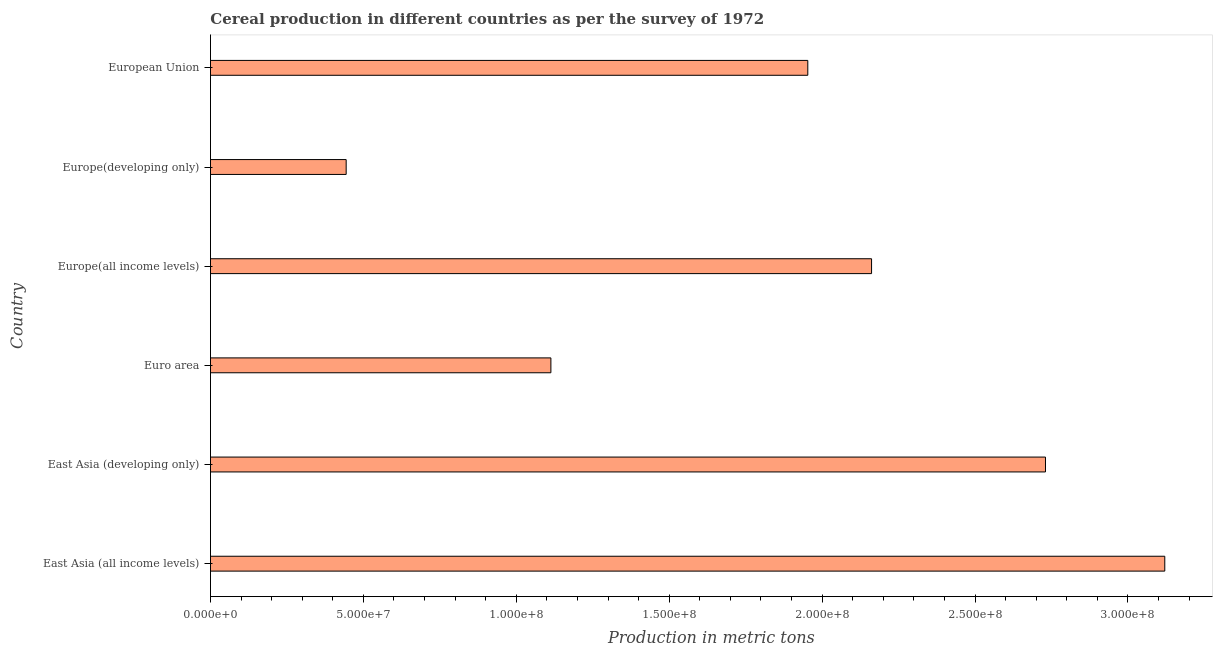Does the graph contain any zero values?
Give a very brief answer. No. Does the graph contain grids?
Offer a terse response. No. What is the title of the graph?
Keep it short and to the point. Cereal production in different countries as per the survey of 1972. What is the label or title of the X-axis?
Your answer should be very brief. Production in metric tons. What is the label or title of the Y-axis?
Keep it short and to the point. Country. What is the cereal production in Europe(developing only)?
Offer a terse response. 4.44e+07. Across all countries, what is the maximum cereal production?
Make the answer very short. 3.12e+08. Across all countries, what is the minimum cereal production?
Offer a very short reply. 4.44e+07. In which country was the cereal production maximum?
Ensure brevity in your answer.  East Asia (all income levels). In which country was the cereal production minimum?
Offer a terse response. Europe(developing only). What is the sum of the cereal production?
Make the answer very short. 1.15e+09. What is the difference between the cereal production in Europe(developing only) and European Union?
Keep it short and to the point. -1.51e+08. What is the average cereal production per country?
Provide a succinct answer. 1.92e+08. What is the median cereal production?
Give a very brief answer. 2.06e+08. In how many countries, is the cereal production greater than 30000000 metric tons?
Offer a very short reply. 6. What is the ratio of the cereal production in Europe(all income levels) to that in European Union?
Keep it short and to the point. 1.11. Is the cereal production in East Asia (all income levels) less than that in Europe(developing only)?
Keep it short and to the point. No. What is the difference between the highest and the second highest cereal production?
Offer a terse response. 3.90e+07. Is the sum of the cereal production in Europe(developing only) and European Union greater than the maximum cereal production across all countries?
Offer a terse response. No. What is the difference between the highest and the lowest cereal production?
Ensure brevity in your answer.  2.68e+08. How many bars are there?
Give a very brief answer. 6. How many countries are there in the graph?
Make the answer very short. 6. Are the values on the major ticks of X-axis written in scientific E-notation?
Offer a very short reply. Yes. What is the Production in metric tons in East Asia (all income levels)?
Your answer should be compact. 3.12e+08. What is the Production in metric tons in East Asia (developing only)?
Offer a terse response. 2.73e+08. What is the Production in metric tons of Euro area?
Your response must be concise. 1.11e+08. What is the Production in metric tons in Europe(all income levels)?
Ensure brevity in your answer.  2.16e+08. What is the Production in metric tons of Europe(developing only)?
Give a very brief answer. 4.44e+07. What is the Production in metric tons of European Union?
Provide a short and direct response. 1.95e+08. What is the difference between the Production in metric tons in East Asia (all income levels) and East Asia (developing only)?
Your answer should be compact. 3.90e+07. What is the difference between the Production in metric tons in East Asia (all income levels) and Euro area?
Offer a terse response. 2.01e+08. What is the difference between the Production in metric tons in East Asia (all income levels) and Europe(all income levels)?
Offer a very short reply. 9.59e+07. What is the difference between the Production in metric tons in East Asia (all income levels) and Europe(developing only)?
Offer a very short reply. 2.68e+08. What is the difference between the Production in metric tons in East Asia (all income levels) and European Union?
Make the answer very short. 1.17e+08. What is the difference between the Production in metric tons in East Asia (developing only) and Euro area?
Offer a terse response. 1.62e+08. What is the difference between the Production in metric tons in East Asia (developing only) and Europe(all income levels)?
Your response must be concise. 5.69e+07. What is the difference between the Production in metric tons in East Asia (developing only) and Europe(developing only)?
Your response must be concise. 2.29e+08. What is the difference between the Production in metric tons in East Asia (developing only) and European Union?
Offer a terse response. 7.77e+07. What is the difference between the Production in metric tons in Euro area and Europe(all income levels)?
Provide a succinct answer. -1.05e+08. What is the difference between the Production in metric tons in Euro area and Europe(developing only)?
Make the answer very short. 6.69e+07. What is the difference between the Production in metric tons in Euro area and European Union?
Your answer should be very brief. -8.40e+07. What is the difference between the Production in metric tons in Europe(all income levels) and Europe(developing only)?
Your response must be concise. 1.72e+08. What is the difference between the Production in metric tons in Europe(all income levels) and European Union?
Make the answer very short. 2.08e+07. What is the difference between the Production in metric tons in Europe(developing only) and European Union?
Provide a short and direct response. -1.51e+08. What is the ratio of the Production in metric tons in East Asia (all income levels) to that in East Asia (developing only)?
Keep it short and to the point. 1.14. What is the ratio of the Production in metric tons in East Asia (all income levels) to that in Euro area?
Your response must be concise. 2.8. What is the ratio of the Production in metric tons in East Asia (all income levels) to that in Europe(all income levels)?
Keep it short and to the point. 1.44. What is the ratio of the Production in metric tons in East Asia (all income levels) to that in Europe(developing only)?
Your response must be concise. 7.03. What is the ratio of the Production in metric tons in East Asia (all income levels) to that in European Union?
Ensure brevity in your answer.  1.6. What is the ratio of the Production in metric tons in East Asia (developing only) to that in Euro area?
Your answer should be very brief. 2.45. What is the ratio of the Production in metric tons in East Asia (developing only) to that in Europe(all income levels)?
Offer a very short reply. 1.26. What is the ratio of the Production in metric tons in East Asia (developing only) to that in Europe(developing only)?
Your response must be concise. 6.15. What is the ratio of the Production in metric tons in East Asia (developing only) to that in European Union?
Provide a succinct answer. 1.4. What is the ratio of the Production in metric tons in Euro area to that in Europe(all income levels)?
Provide a succinct answer. 0.52. What is the ratio of the Production in metric tons in Euro area to that in Europe(developing only)?
Your answer should be compact. 2.51. What is the ratio of the Production in metric tons in Euro area to that in European Union?
Make the answer very short. 0.57. What is the ratio of the Production in metric tons in Europe(all income levels) to that in Europe(developing only)?
Ensure brevity in your answer.  4.87. What is the ratio of the Production in metric tons in Europe(all income levels) to that in European Union?
Offer a very short reply. 1.11. What is the ratio of the Production in metric tons in Europe(developing only) to that in European Union?
Ensure brevity in your answer.  0.23. 